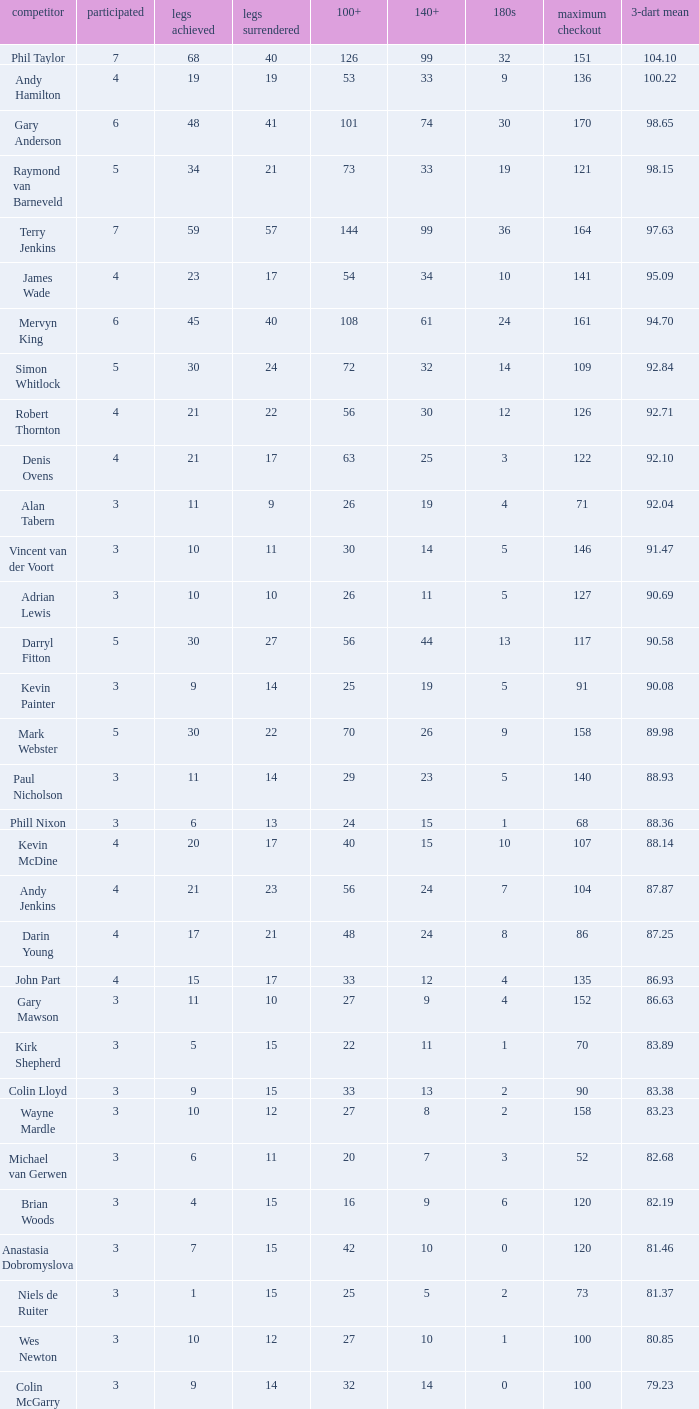What is the high checkout when Legs Won is smaller than 9, a 180s of 1, and a 3-dart Average larger than 88.36? None. 